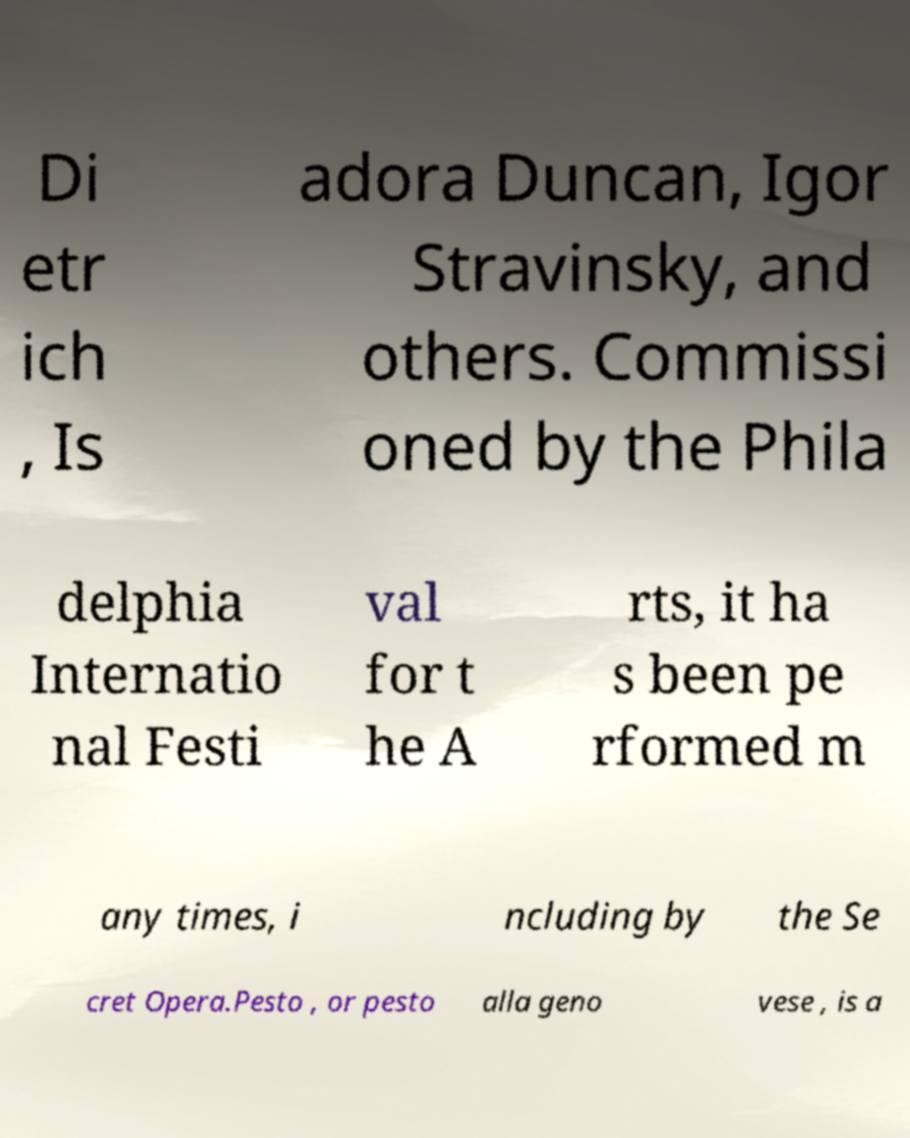I need the written content from this picture converted into text. Can you do that? Di etr ich , Is adora Duncan, Igor Stravinsky, and others. Commissi oned by the Phila delphia Internatio nal Festi val for t he A rts, it ha s been pe rformed m any times, i ncluding by the Se cret Opera.Pesto , or pesto alla geno vese , is a 